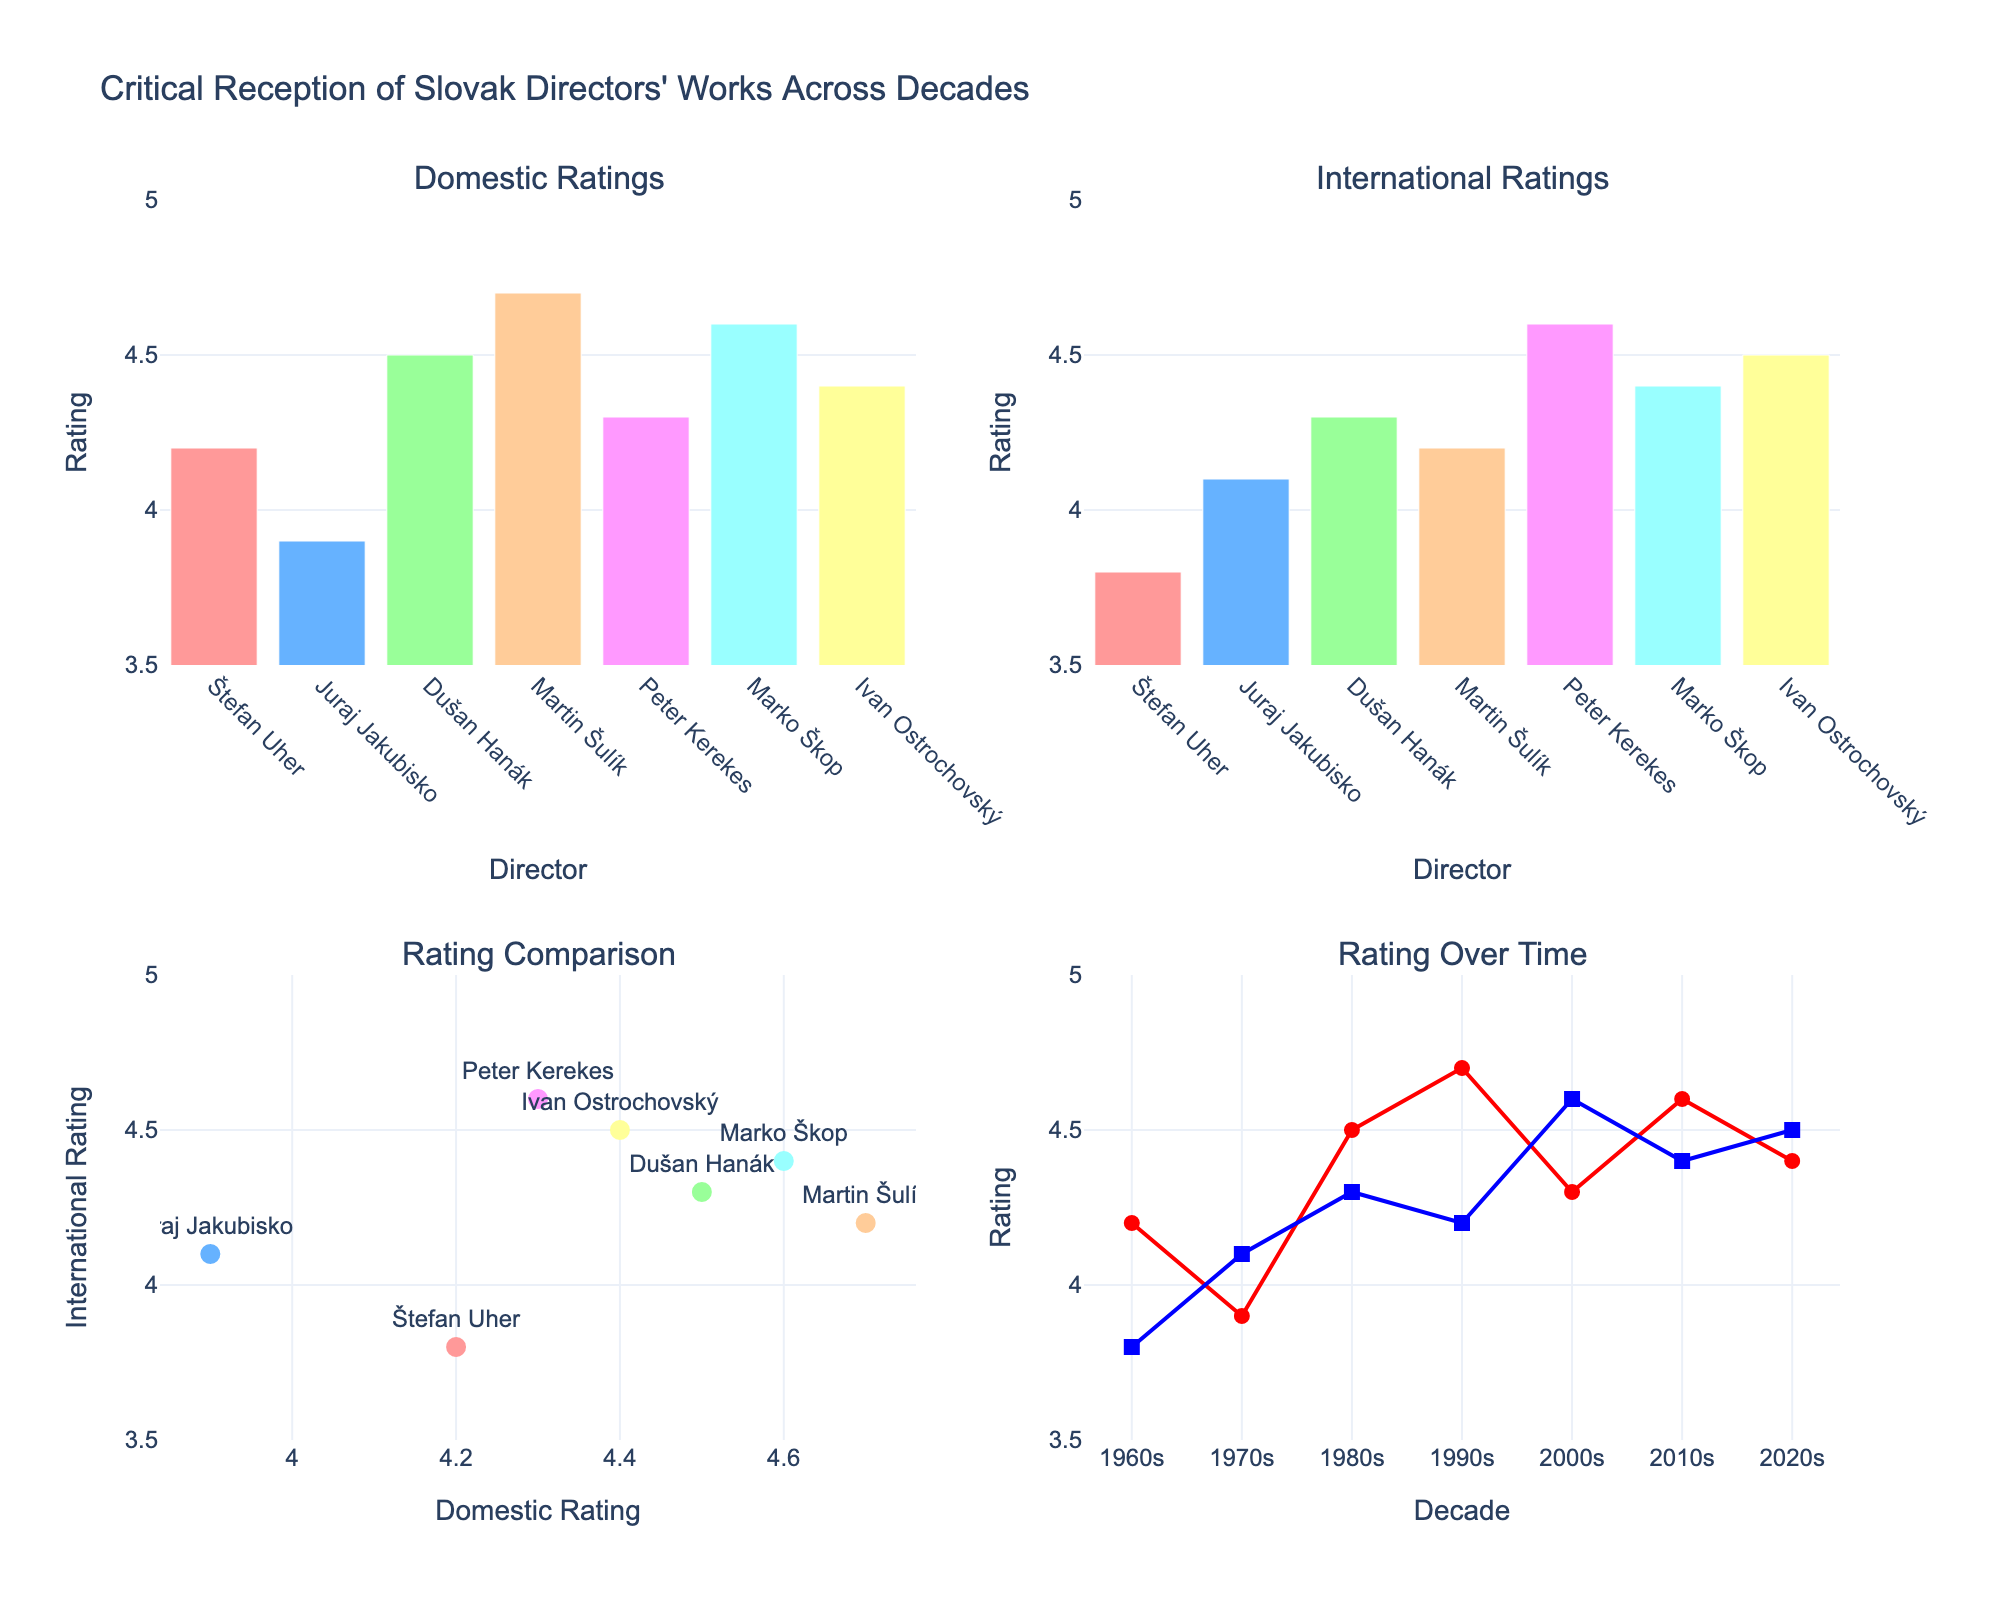which director received the highest domestic rating? From the Domestic Ratings subplot, the highest bar is Martin Šulík for 'The Garden', with a rating of 4.7.
Answer: Martin Šulík how do the international ratings of the 1960s and 2020s compare? From the International Ratings subplot, Štefan Uher's 'The Sun in a Net' (1960s) received a 3.8, while Ivan Ostrochovský's 'Servants' (2020s) received a 4.5.
Answer: 2020s are higher which director has the smallest difference between domestic and international ratings? From the Rating Comparison subplot, Dušan Hanák ('I Love You Love') has very close ratings: domestic 4.5 and international 4.3. The difference is 0.2.
Answer: Dušan Hanák have domestic ratings generally increased or decreased over time? Examining the Rating Over Time subplot, domestic ratings start at 4.2 in the 1960s and fluctuate but show an increasing trend, reaching 4.4 in the 2020s.
Answer: Increased what is the decade with the highest average international rating? From the line chart in the Rating Over Time subplot, all international ratings for individual films in each decade can be averaged. 2000s have the highest rating (4.6).
Answer: 2000s which two directors have similar international ratings but different domestic ratings? From the Rating Comparison subplot, Ivan Ostrochovský ('Servants') and Peter Kerekes ('66 Seasons') have similar international ratings (4.5 and 4.6), but different domestic ratings (4.4 and 4.3).
Answer: Ivan Ostrochovský and Peter Kerekes what patterns can be observed in the rating comparisons between domestic and international ratings? The Rating Comparison subplot indicates that generally, domestic ratings tend to be slightly higher than international ratings for most directors, except for a few cases like Peter Kerekes.
Answer: Domestic ratings generally higher 